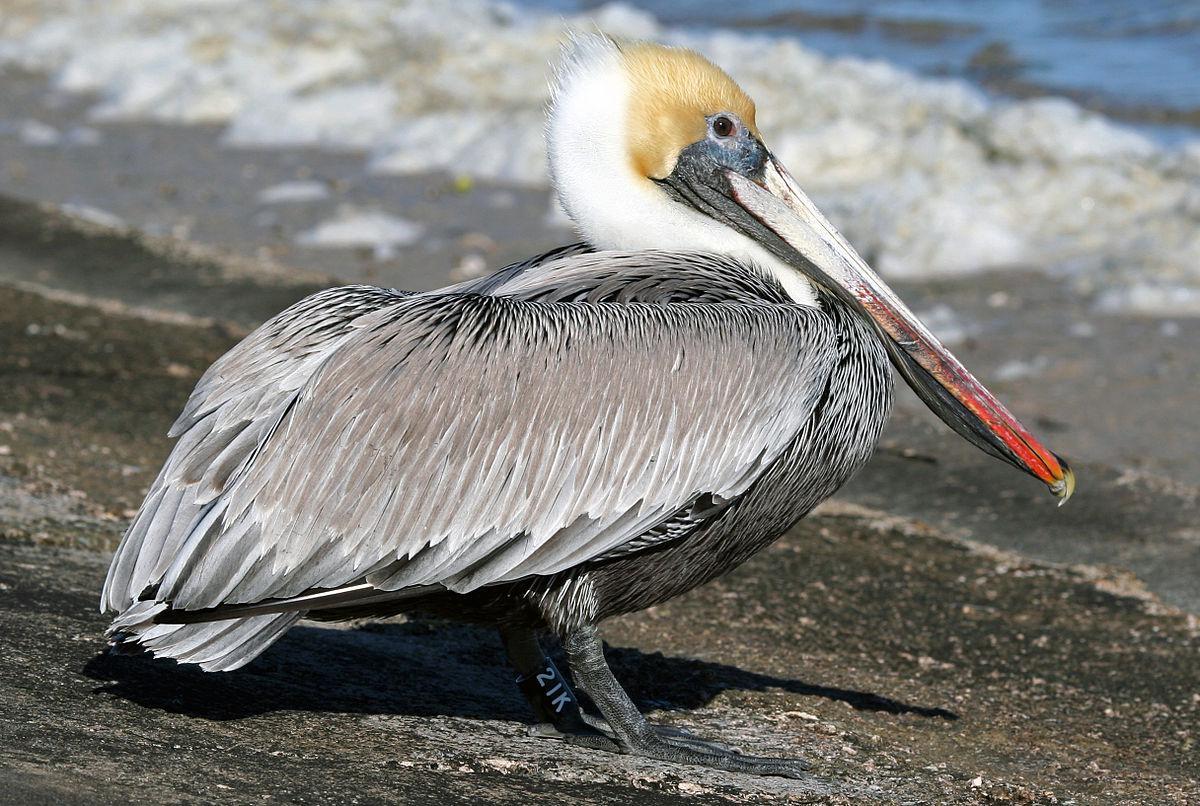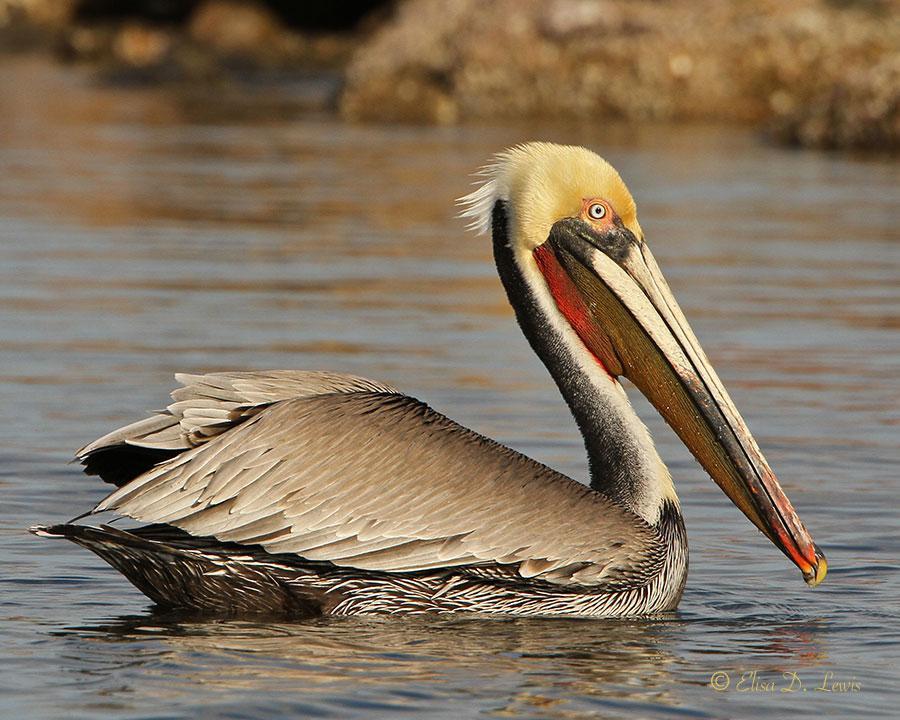The first image is the image on the left, the second image is the image on the right. Examine the images to the left and right. Is the description "The right image shows a pelican afloat on the water." accurate? Answer yes or no. Yes. 